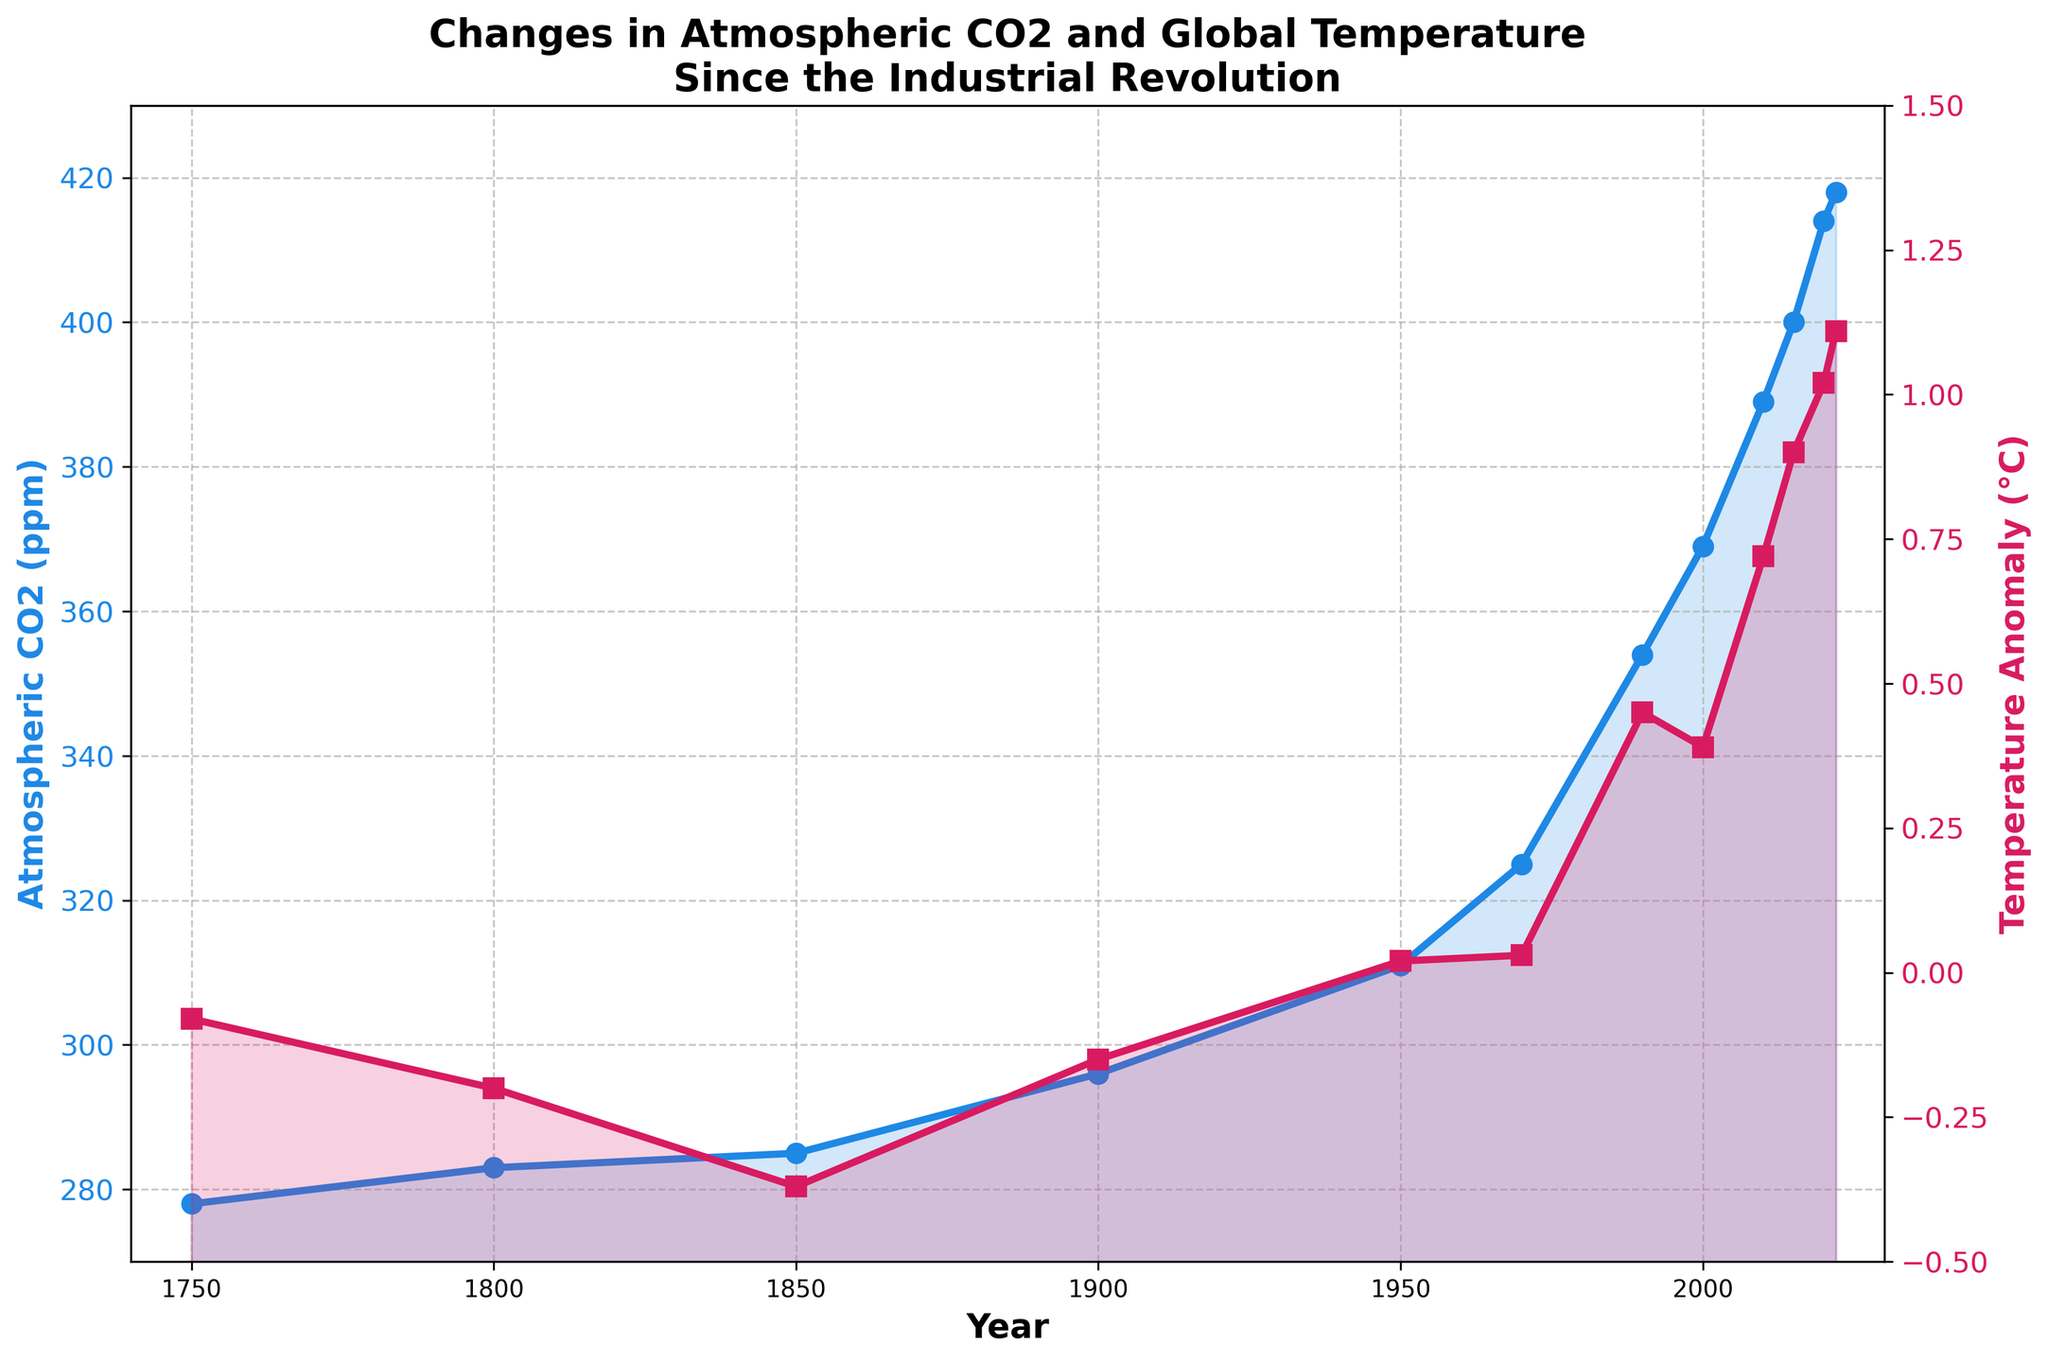What's the earliest year with a recorded temperature anomaly higher than 0°C? First, locate the temperature anomaly line (red) and identify when it crosses above 0°C. It happens between 1950 and 1990. Check the specific values and see that the year is 1990 when the temperature anomaly first exceeds 0°C.
Answer: 1990 What is the difference in atmospheric CO2 levels between 1750 and 2022? Locate the atmospheric CO2 levels (blue line) for the years 1750 and 2022. In 1750, CO2 levels are 278 ppm; in 2022, they are 418 ppm. Subtract the earlier value from the latter, 418 - 278.
Answer: 140 ppm In which period did the most significant increase in temperature anomaly occur? Check the temperature anomaly values (red line) for significant jumps. The anomaly increases noticeably from 0.72°C in 2010 to 0.90°C in 2015, a span of five years showing the most marked increase.
Answer: 2010-2015 How much did atmospheric CO2 levels increase between 1800 and 1850? Observe the atmospheric CO2 values (blue line) for the years 1800 and 1850. In 1800, it is 283 ppm, and in 1850, it is 285 ppm. The difference is 285 - 283.
Answer: 2 ppm Compare the temperature anomalies of 1950 and 2022, which year had the higher anomaly and by how much? Locate the temperature anomaly values (red line) for 1950 and 2022. In 1950, it is 0.02°C, and in 2022, it is 1.11°C. Subtract the 1950 value from the 2022 value, 1.11 - 0.02.
Answer: 2022 by 1.09°C By how many ppm did atmospheric CO2 levels change from 1900 to 2000? Check the atmospheric CO2 levels (blue line) for 1900 and 2000. In 1900, CO2 is at 296 ppm; in 2000, it is at 369 ppm. Subtract 296 from 369.
Answer: 73 ppm What is the average temperature anomaly recorded between 2000 and 2020? Look at the red line for the years 2000, 2010, and 2020. The anomalies are 0.39°C, 0.72°C, and 1.02°C, respectively. Compute the average: (0.39 + 0.72 + 1.02) / 3.
Answer: 0.71°C Which year had the highest atmospheric CO2 levels? Identify the highest point on the blue CO2 line. The peak value is for the year 2022, with a level of 418 ppm.
Answer: 2022 If atmospheric CO2 levels and temperature anomaly from 1850 were averaged over all given years, what would be the results? Gather data for all years from the blue and red lines: CO2 levels (278, 283, 285, 296, 311, 325, 354, 369, 389, 400, 414, 418) and temperature anomalies (-0.08, -0.20, -0.37, -0.15, 0.02, 0.03, 0.45, 0.39, 0.72, 0.90, 1.02, 1.11). Calculate the averages separately: CO2 average = (278+283+285+296+311+325+354+369+389+400+414+418)/12, and temperature anomaly average = (-0.08-0.20-0.37-0.15+0.02+0.03+0.45+0.39+0.72+0.90+1.02+1.11)/12.
Answer: CO2: 349.42 ppm, Temperature: 0.31°C 